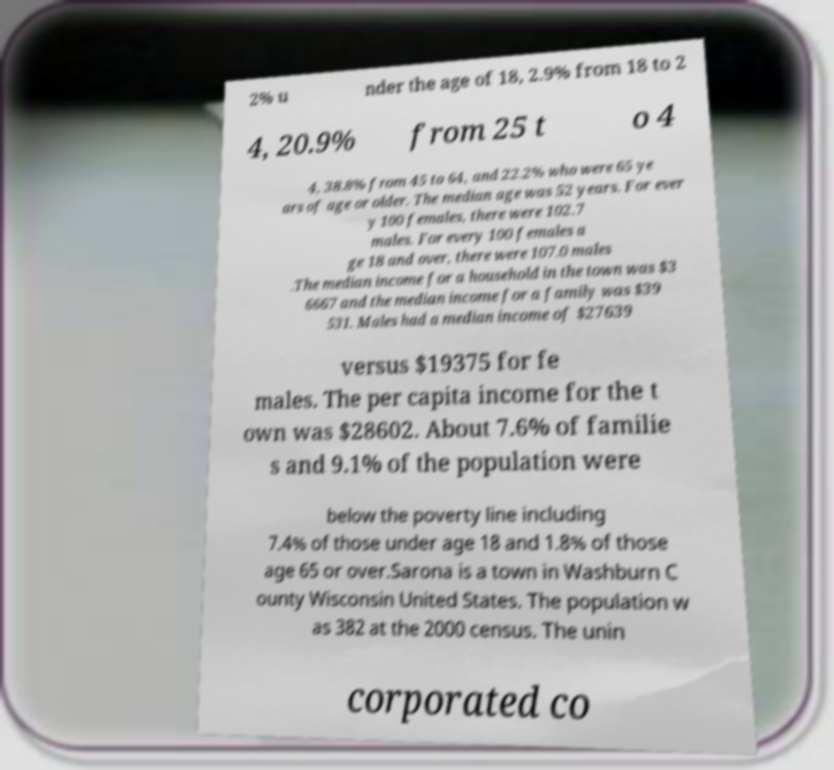Can you accurately transcribe the text from the provided image for me? 2% u nder the age of 18, 2.9% from 18 to 2 4, 20.9% from 25 t o 4 4, 38.8% from 45 to 64, and 22.2% who were 65 ye ars of age or older. The median age was 52 years. For ever y 100 females, there were 102.7 males. For every 100 females a ge 18 and over, there were 107.0 males .The median income for a household in the town was $3 6667 and the median income for a family was $39 531. Males had a median income of $27639 versus $19375 for fe males. The per capita income for the t own was $28602. About 7.6% of familie s and 9.1% of the population were below the poverty line including 7.4% of those under age 18 and 1.8% of those age 65 or over.Sarona is a town in Washburn C ounty Wisconsin United States. The population w as 382 at the 2000 census. The unin corporated co 